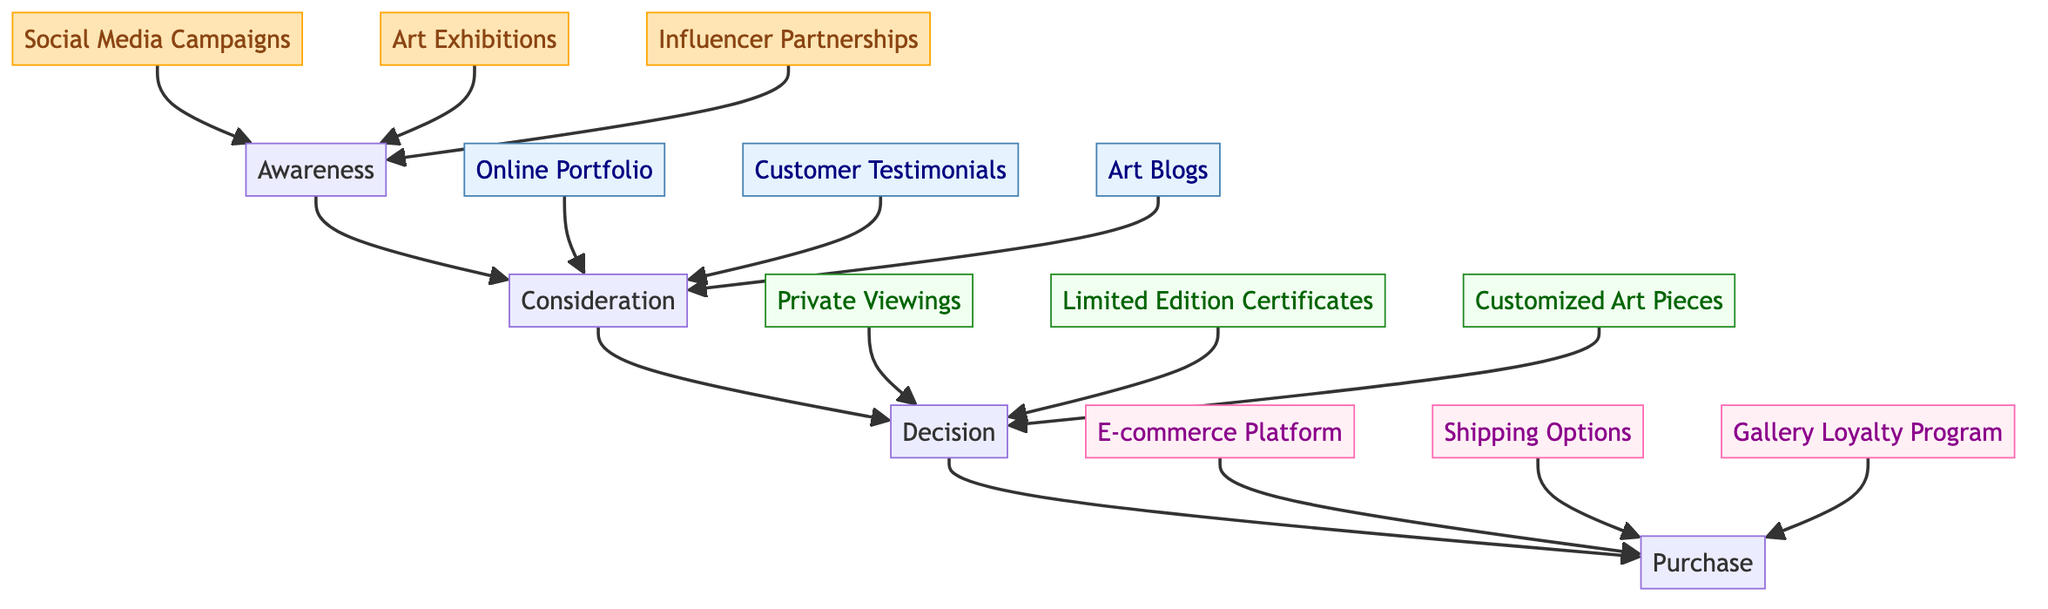What is the first stage in the customer journey? The diagram depicts "Awareness" as the first node in the customer journey, clearly indicating the starting stage for art buyers.
Answer: Awareness How many elements are there in the Decision stage? In the Decision stage, there are three elements connected to it: Private Viewings, Limited Edition Certificates, and Customized Art Pieces.
Answer: 3 What connects the Awareness stage to the Consideration stage? The arrow from the Awareness stage leads to the Consideration stage, indicating a direct transition, signifying that awareness influences consideration in the customer journey.
Answer: Consideration Which social media platform is mentioned in the Awareness stage? The diagram indicates "Social Media Campaigns" as an element in the Awareness stage, with a focus on Instagram as the platform for engaging posts.
Answer: Instagram Which element in the Purchase stage is aimed at repeat buyers? The element "Gallery Loyalty Program" in the Purchase stage specifically targets repeat buyers by offering incentives such as discounts or exclusive previews.
Answer: Gallery Loyalty Program What type of partnerships are indicated in the Awareness stage? The element "Influencer Partnerships" in the Awareness stage refers to collaborations with influencers, specifically in the marine conservation field to promote the artwork.
Answer: Influencer Partnerships What is the final stage in the customer journey? The diagram shows that the last stage in the customer journey is "Purchase," indicating it as the concluding action after consideration and decision-making stages.
Answer: Purchase Which collection showcases the shark photographs? The element "Online Portfolio" in the Consideration stage is specifically designed to showcase a curated collection of shark photographs.
Answer: Online Portfolio What option is provided for buyers in the Decision stage? In the Decision stage, one option provided is "Customized Art Pieces," allowing buyers to request bespoke art pieces based on their preferences.
Answer: Customized Art Pieces 